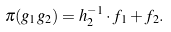<formula> <loc_0><loc_0><loc_500><loc_500>\pi ( g _ { 1 } g _ { 2 } ) = h _ { 2 } ^ { - 1 } \cdot f _ { 1 } + f _ { 2 } .</formula> 